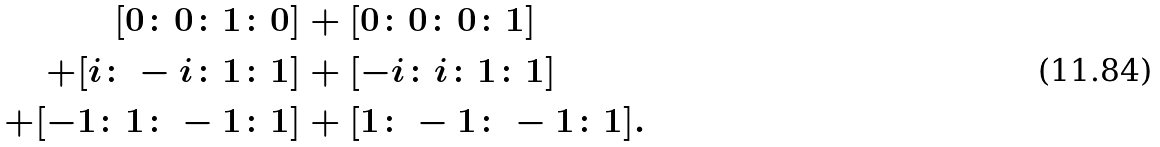<formula> <loc_0><loc_0><loc_500><loc_500>[ 0 \colon 0 \colon 1 \colon 0 ] & + [ 0 \colon 0 \colon 0 \colon 1 ] \\ + [ i \colon - i \colon 1 \colon 1 ] & + [ - i \colon i \colon 1 \colon 1 ] \\ + [ - 1 \colon 1 \colon - 1 \colon 1 ] & + [ 1 \colon - 1 \colon - 1 \colon 1 ] .</formula> 